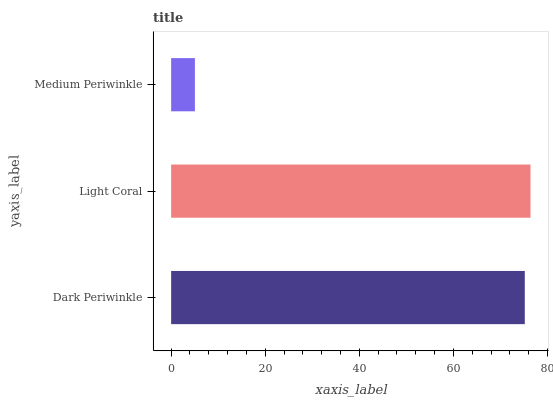Is Medium Periwinkle the minimum?
Answer yes or no. Yes. Is Light Coral the maximum?
Answer yes or no. Yes. Is Light Coral the minimum?
Answer yes or no. No. Is Medium Periwinkle the maximum?
Answer yes or no. No. Is Light Coral greater than Medium Periwinkle?
Answer yes or no. Yes. Is Medium Periwinkle less than Light Coral?
Answer yes or no. Yes. Is Medium Periwinkle greater than Light Coral?
Answer yes or no. No. Is Light Coral less than Medium Periwinkle?
Answer yes or no. No. Is Dark Periwinkle the high median?
Answer yes or no. Yes. Is Dark Periwinkle the low median?
Answer yes or no. Yes. Is Medium Periwinkle the high median?
Answer yes or no. No. Is Medium Periwinkle the low median?
Answer yes or no. No. 